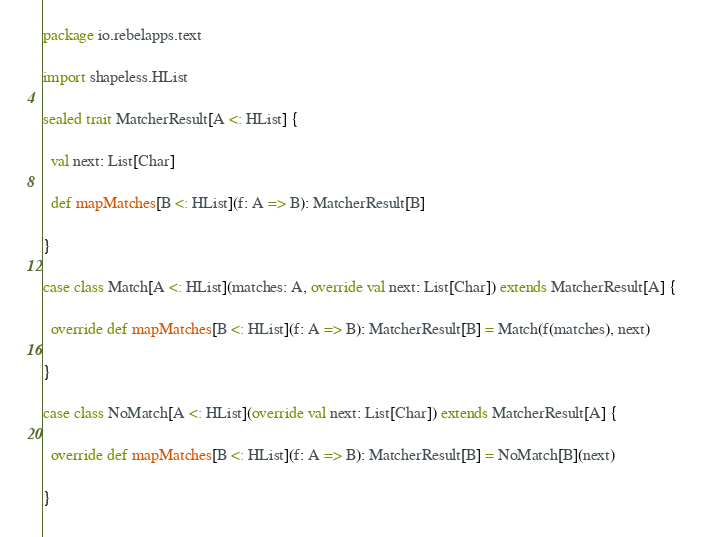Convert code to text. <code><loc_0><loc_0><loc_500><loc_500><_Scala_>package io.rebelapps.text

import shapeless.HList

sealed trait MatcherResult[A <: HList] {

  val next: List[Char]

  def mapMatches[B <: HList](f: A => B): MatcherResult[B]

}

case class Match[A <: HList](matches: A, override val next: List[Char]) extends MatcherResult[A] {

  override def mapMatches[B <: HList](f: A => B): MatcherResult[B] = Match(f(matches), next)

}

case class NoMatch[A <: HList](override val next: List[Char]) extends MatcherResult[A] {

  override def mapMatches[B <: HList](f: A => B): MatcherResult[B] = NoMatch[B](next)

}</code> 